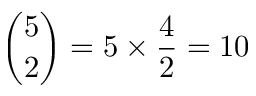Convert formula to latex. <formula><loc_0><loc_0><loc_500><loc_500>{ \binom { 5 } { 2 } } = 5 \times { \frac { 4 } { 2 } } = 1 0</formula> 